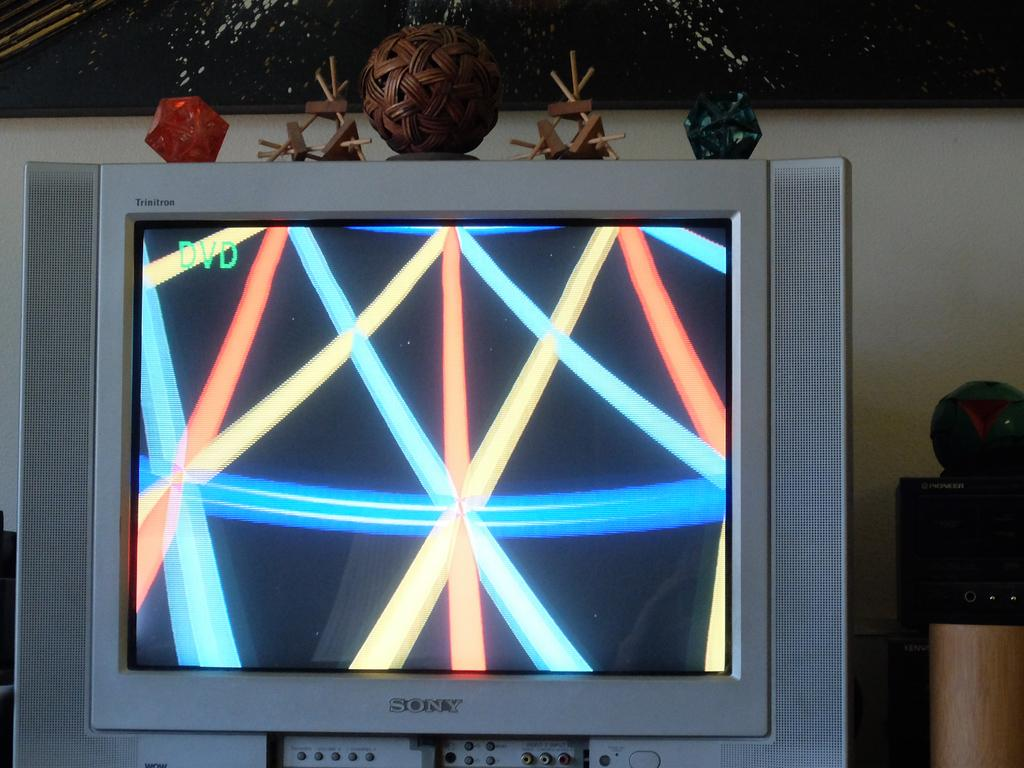<image>
Render a clear and concise summary of the photo. An old model of a television set made by Sony. 